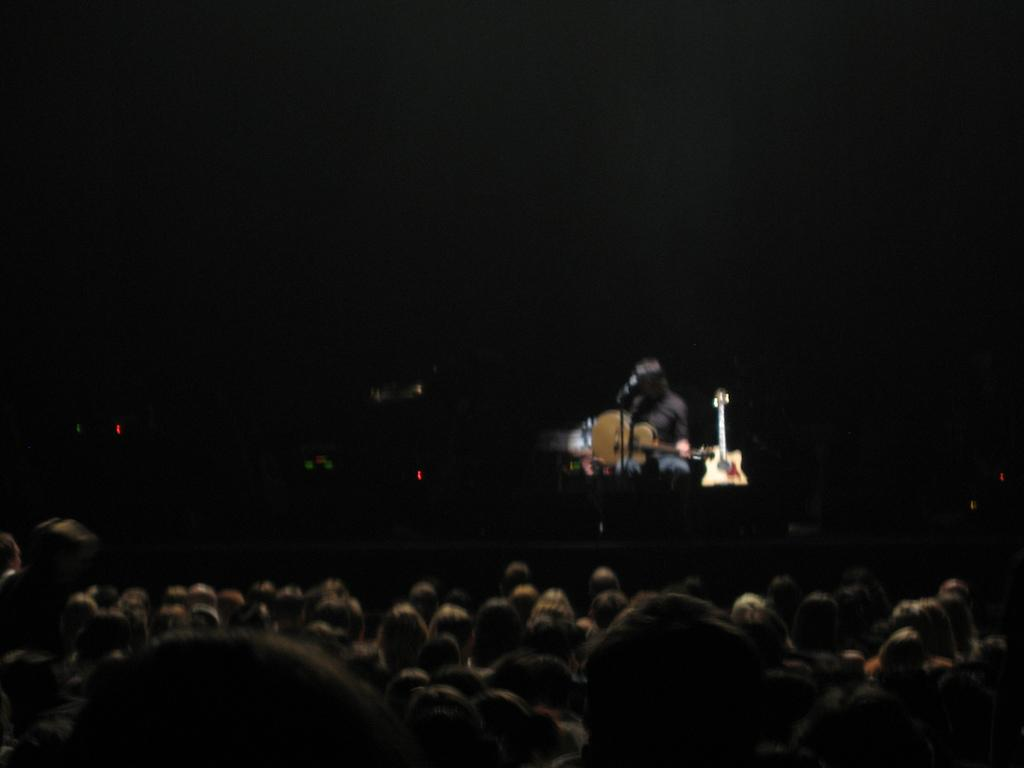What is happening at the bottom of the image? There are people sitting at the bottom of the image. What is the main object in the middle of the image? There is a screen in the middle of the image. What is the person in the screen doing? The person in the screen is holding a guitar. What type of spade is the person in the screen using to dig a plot? There is no spade or digging activity present in the image. What is the tendency of the person in the screen to play the guitar? The image does not provide information about the person's tendency to play the guitar; it only shows the person holding a guitar. 